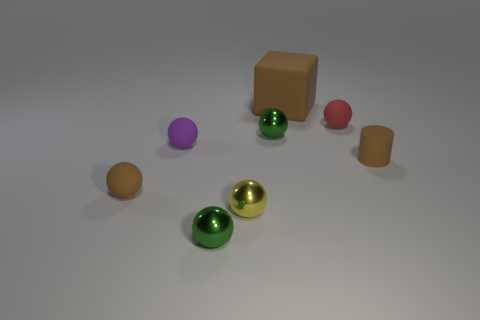There is a small thing that is the same color as the small cylinder; what is it made of?
Your response must be concise. Rubber. What size is the ball that is the same color as the big object?
Your answer should be compact. Small. There is a green ball that is in front of the matte cylinder; is it the same size as the brown thing behind the purple sphere?
Your answer should be very brief. No. How many other objects are the same shape as the purple rubber object?
Your answer should be very brief. 5. There is a tiny green object that is in front of the tiny brown rubber object that is right of the big rubber cube; what is its material?
Your answer should be compact. Metal. What number of metal things are small purple spheres or big brown cubes?
Keep it short and to the point. 0. Are there any other things that are made of the same material as the brown ball?
Your response must be concise. Yes. Is there a green object that is right of the brown matte object that is behind the red ball?
Provide a short and direct response. No. How many things are either tiny rubber objects on the right side of the red object or yellow metallic things right of the tiny purple matte ball?
Your response must be concise. 2. Are there any other things of the same color as the cube?
Offer a very short reply. Yes. 